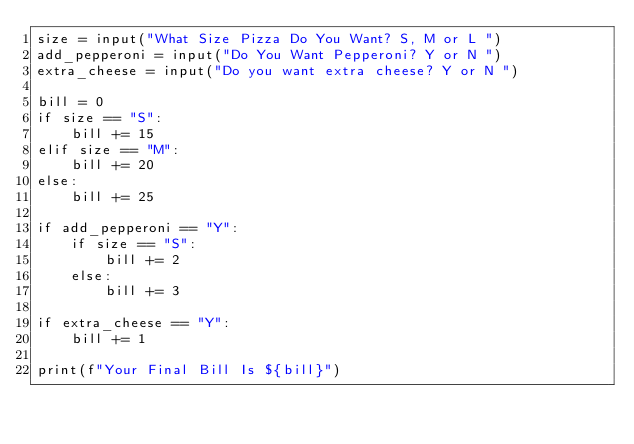<code> <loc_0><loc_0><loc_500><loc_500><_Python_>size = input("What Size Pizza Do You Want? S, M or L ")
add_pepperoni = input("Do You Want Pepperoni? Y or N ")
extra_cheese = input("Do you want extra cheese? Y or N ")

bill = 0
if size == "S":
    bill += 15
elif size == "M":
    bill += 20
else:
    bill += 25

if add_pepperoni == "Y":
    if size == "S":
        bill += 2
    else:
        bill += 3

if extra_cheese == "Y":
    bill += 1

print(f"Your Final Bill Is ${bill}")
</code> 